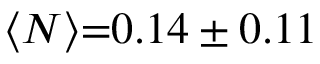<formula> <loc_0><loc_0><loc_500><loc_500>\langle N \rangle { = } 0 . 1 4 \pm 0 . 1 1</formula> 